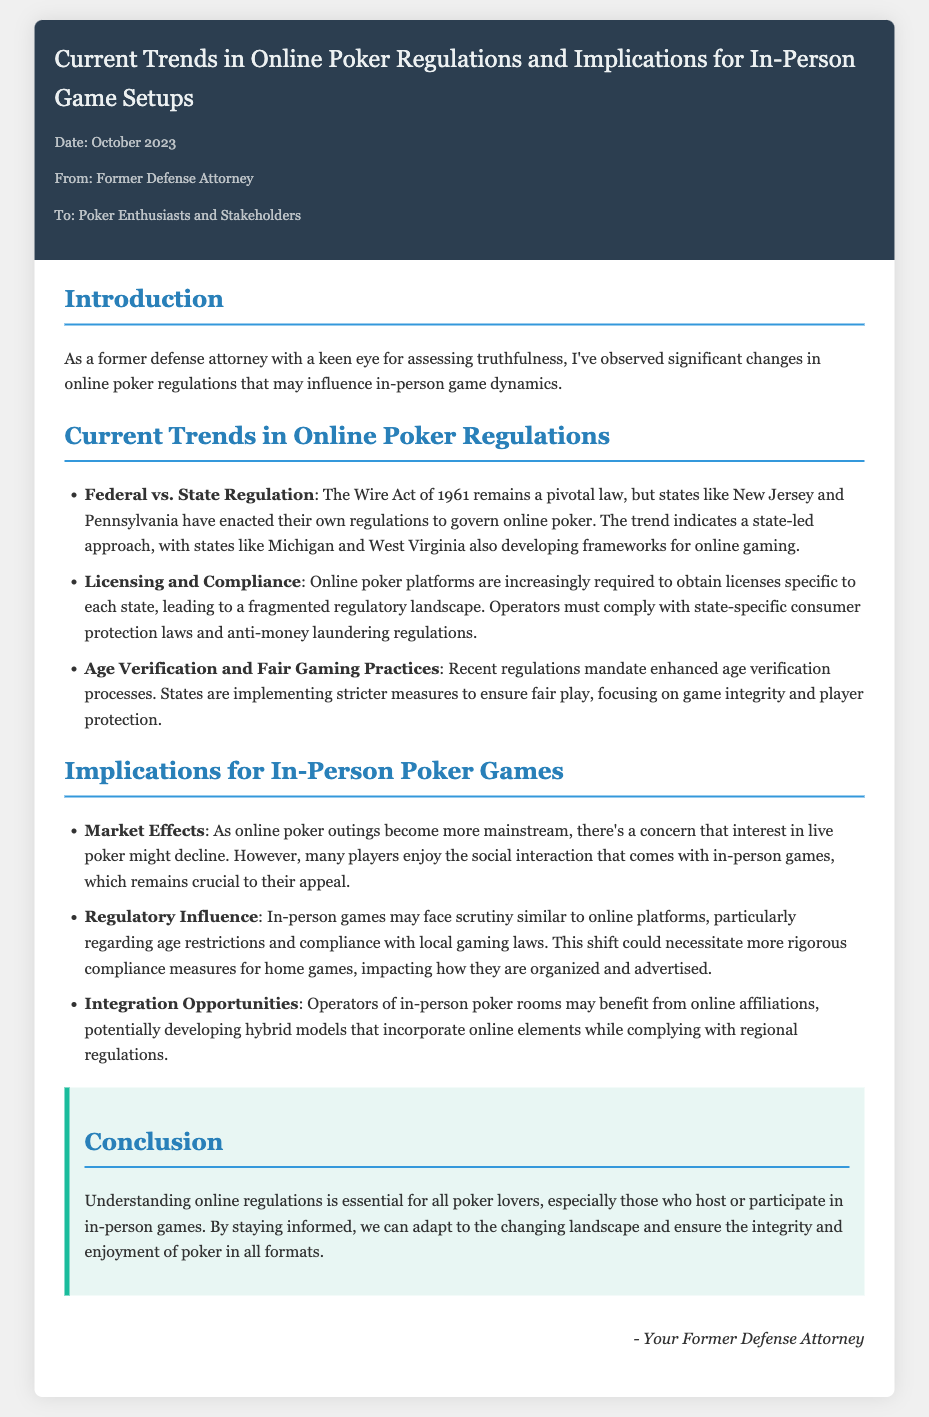What is the date of the memo? The date is specified in the meta section of the document.
Answer: October 2023 Who is the memo addressed to? The recipient of the memo is mentioned in the meta section.
Answer: Poker Enthusiasts and Stakeholders What law remains pivotal for online poker? The law referenced in the document regarding online poker is indicated in the regulations section.
Answer: Wire Act of 1961 Which states are developing frameworks for online gaming? The document lists specific states that are involved in developing online gaming frameworks.
Answer: Michigan and West Virginia What is a key concern about the interest in live poker? The memo mentions a specific concern related to the interest in poker formats.
Answer: Decline What is necessary for home games according to the memo? The document explains what may be necessary for home games due to regulatory scrutiny.
Answer: Compliance measures What type of verification processes are mandated by recent regulations? The nature of the verification processes required is discussed in the regulations section.
Answer: Age verification How might in-person poker rooms benefit from online affiliations? The memo describes potential benefits of online affiliations to in-person poker operators.
Answer: Hybrid models What overarching theme does the conclusion emphasize? The conclusion stresses a specific aspect related to the understanding of regulations for poker lovers.
Answer: Understanding online regulations 